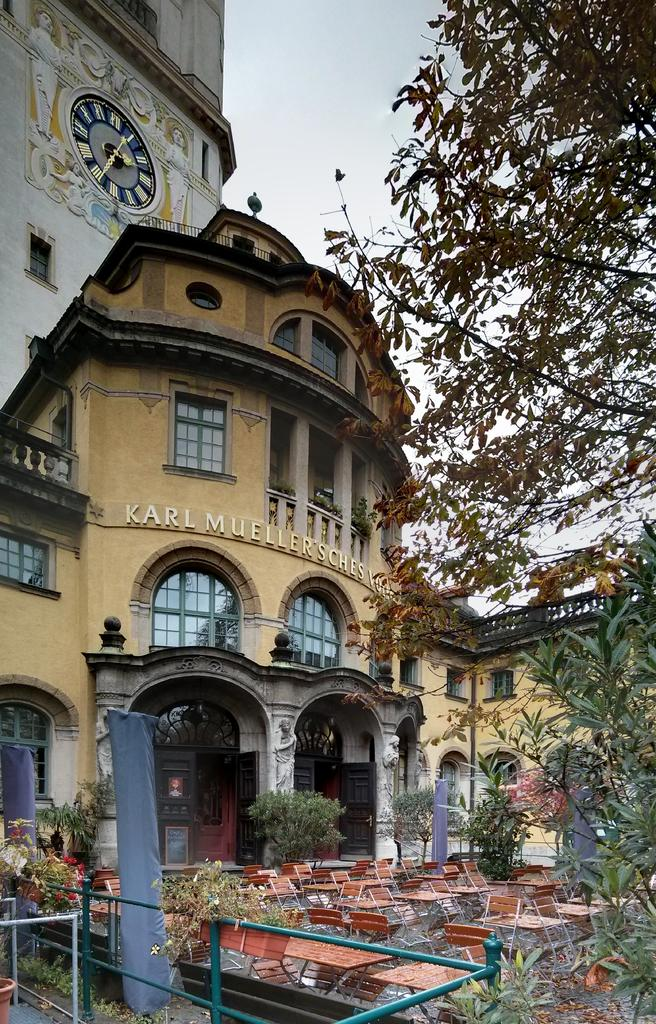What type of structure is visible in the image? There is a building in the image. What other elements can be seen in the image besides the building? There are plants and a branch on the right side of the image. Is there any indication of time in the image? Yes, there is a clock on the wall in the image. What can be seen in the sky in the image? The sky is visible at the top of the image. What type of answer can be seen written on the girl's baseball in the image? There is no girl or baseball present in the image. 